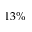Convert formula to latex. <formula><loc_0><loc_0><loc_500><loc_500>1 3 \%</formula> 